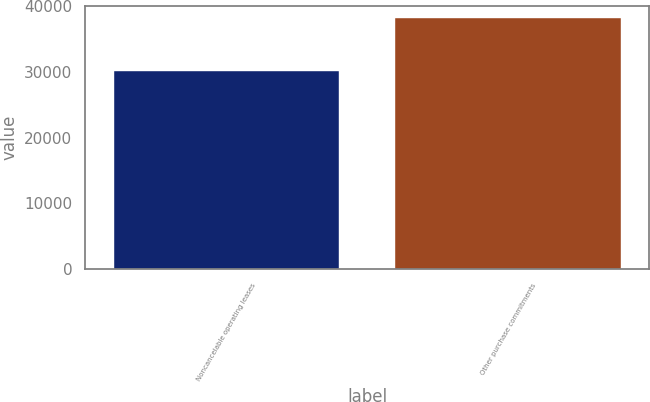Convert chart to OTSL. <chart><loc_0><loc_0><loc_500><loc_500><bar_chart><fcel>Noncancelable operating leases<fcel>Other purchase commitments<nl><fcel>30093<fcel>38100<nl></chart> 